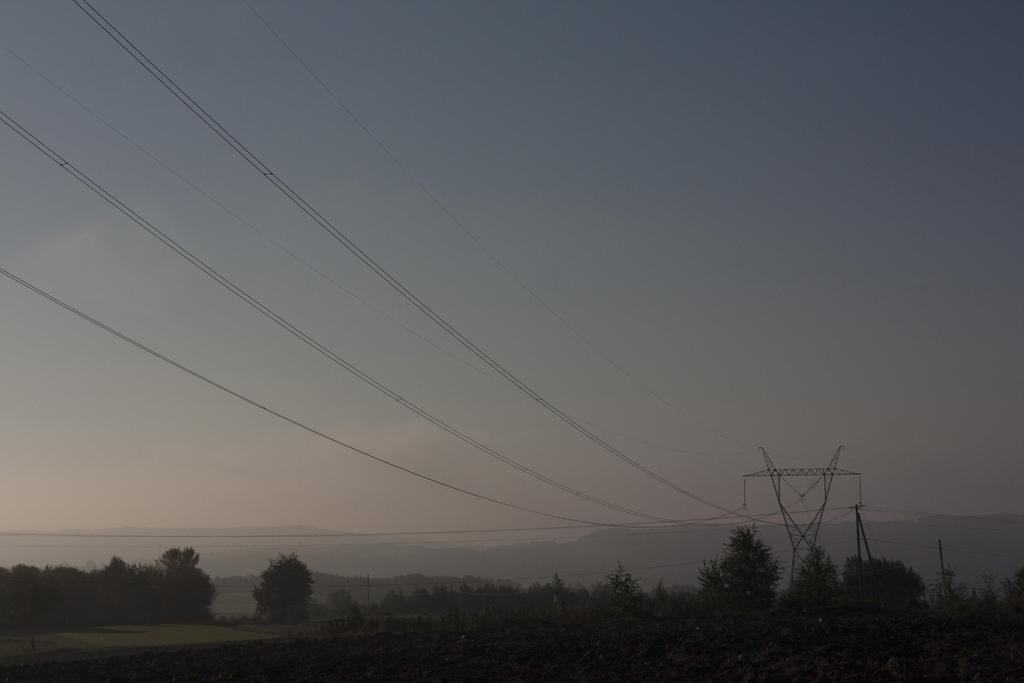What type of landscape is depicted in the image? The image features hills. What structure can be seen in the image? There is a tower in the image. What objects are present in the image that are related to electricity or communication? There are poles and wires in the image. What type of vegetation is visible in the image? There are trees in the image. How much does the powder cost in the image? There is no powder present in the image, so it is not possible to determine its cost. 